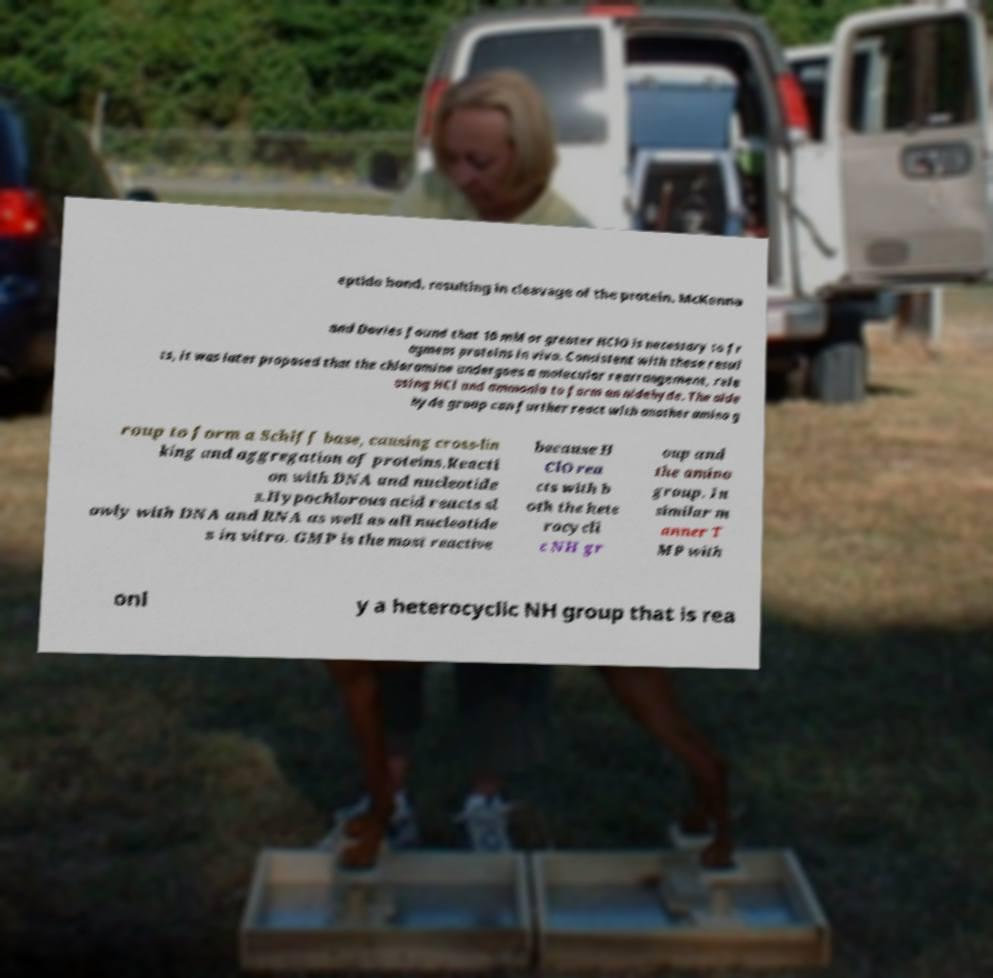Please identify and transcribe the text found in this image. eptide bond, resulting in cleavage of the protein. McKenna and Davies found that 10 mM or greater HClO is necessary to fr agment proteins in vivo. Consistent with these resul ts, it was later proposed that the chloramine undergoes a molecular rearrangement, rele asing HCl and ammonia to form an aldehyde. The alde hyde group can further react with another amino g roup to form a Schiff base, causing cross-lin king and aggregation of proteins.Reacti on with DNA and nucleotide s.Hypochlorous acid reacts sl owly with DNA and RNA as well as all nucleotide s in vitro. GMP is the most reactive because H ClO rea cts with b oth the hete rocycli c NH gr oup and the amino group. In similar m anner T MP with onl y a heterocyclic NH group that is rea 